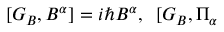Convert formula to latex. <formula><loc_0><loc_0><loc_500><loc_500>[ G _ { B } , B ^ { \alpha } ] = i \hbar { B } ^ { \alpha } , \, [ G _ { B } , \Pi _ { \alpha }</formula> 